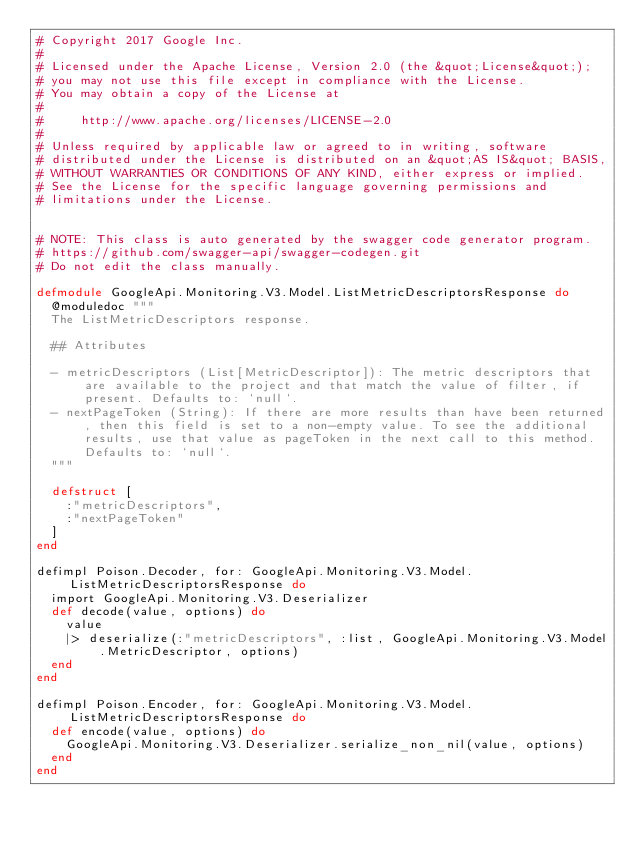<code> <loc_0><loc_0><loc_500><loc_500><_Elixir_># Copyright 2017 Google Inc.
#
# Licensed under the Apache License, Version 2.0 (the &quot;License&quot;);
# you may not use this file except in compliance with the License.
# You may obtain a copy of the License at
#
#     http://www.apache.org/licenses/LICENSE-2.0
#
# Unless required by applicable law or agreed to in writing, software
# distributed under the License is distributed on an &quot;AS IS&quot; BASIS,
# WITHOUT WARRANTIES OR CONDITIONS OF ANY KIND, either express or implied.
# See the License for the specific language governing permissions and
# limitations under the License.


# NOTE: This class is auto generated by the swagger code generator program.
# https://github.com/swagger-api/swagger-codegen.git
# Do not edit the class manually.

defmodule GoogleApi.Monitoring.V3.Model.ListMetricDescriptorsResponse do
  @moduledoc """
  The ListMetricDescriptors response.

  ## Attributes

  - metricDescriptors (List[MetricDescriptor]): The metric descriptors that are available to the project and that match the value of filter, if present. Defaults to: `null`.
  - nextPageToken (String): If there are more results than have been returned, then this field is set to a non-empty value. To see the additional results, use that value as pageToken in the next call to this method. Defaults to: `null`.
  """

  defstruct [
    :"metricDescriptors",
    :"nextPageToken"
  ]
end

defimpl Poison.Decoder, for: GoogleApi.Monitoring.V3.Model.ListMetricDescriptorsResponse do
  import GoogleApi.Monitoring.V3.Deserializer
  def decode(value, options) do
    value
    |> deserialize(:"metricDescriptors", :list, GoogleApi.Monitoring.V3.Model.MetricDescriptor, options)
  end
end

defimpl Poison.Encoder, for: GoogleApi.Monitoring.V3.Model.ListMetricDescriptorsResponse do
  def encode(value, options) do
    GoogleApi.Monitoring.V3.Deserializer.serialize_non_nil(value, options)
  end
end

</code> 